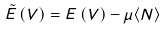Convert formula to latex. <formula><loc_0><loc_0><loc_500><loc_500>\tilde { E } \left ( V \right ) = E \left ( V \right ) - \mu \langle N \rangle</formula> 